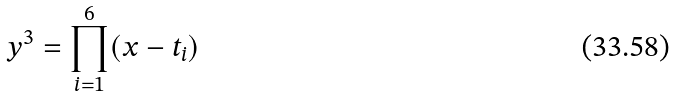Convert formula to latex. <formula><loc_0><loc_0><loc_500><loc_500>y ^ { 3 } = \prod _ { i = 1 } ^ { 6 } ( x - t _ { i } )</formula> 